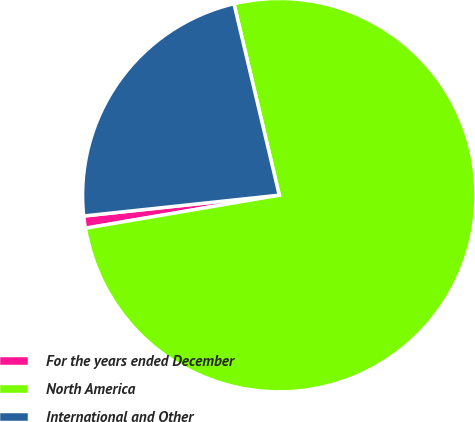Convert chart to OTSL. <chart><loc_0><loc_0><loc_500><loc_500><pie_chart><fcel>For the years ended December<fcel>North America<fcel>International and Other<nl><fcel>1.0%<fcel>76.01%<fcel>22.99%<nl></chart> 